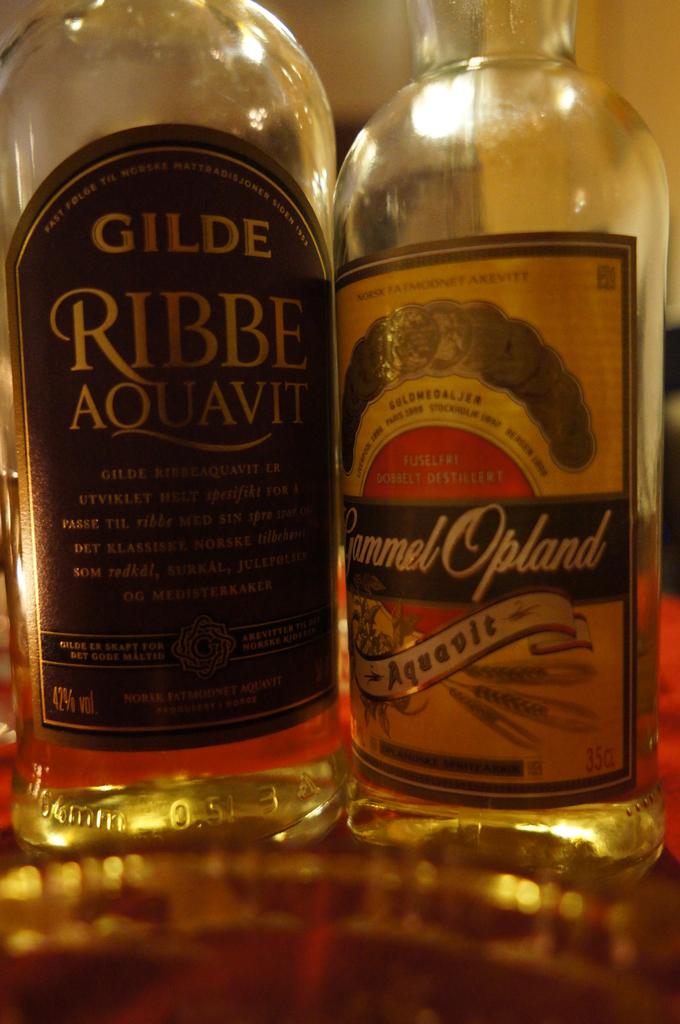What brand of liquor is in the bottle on the left?
Offer a terse response. Gilde. What brand is on the right?
Ensure brevity in your answer.  Gammel opland. 